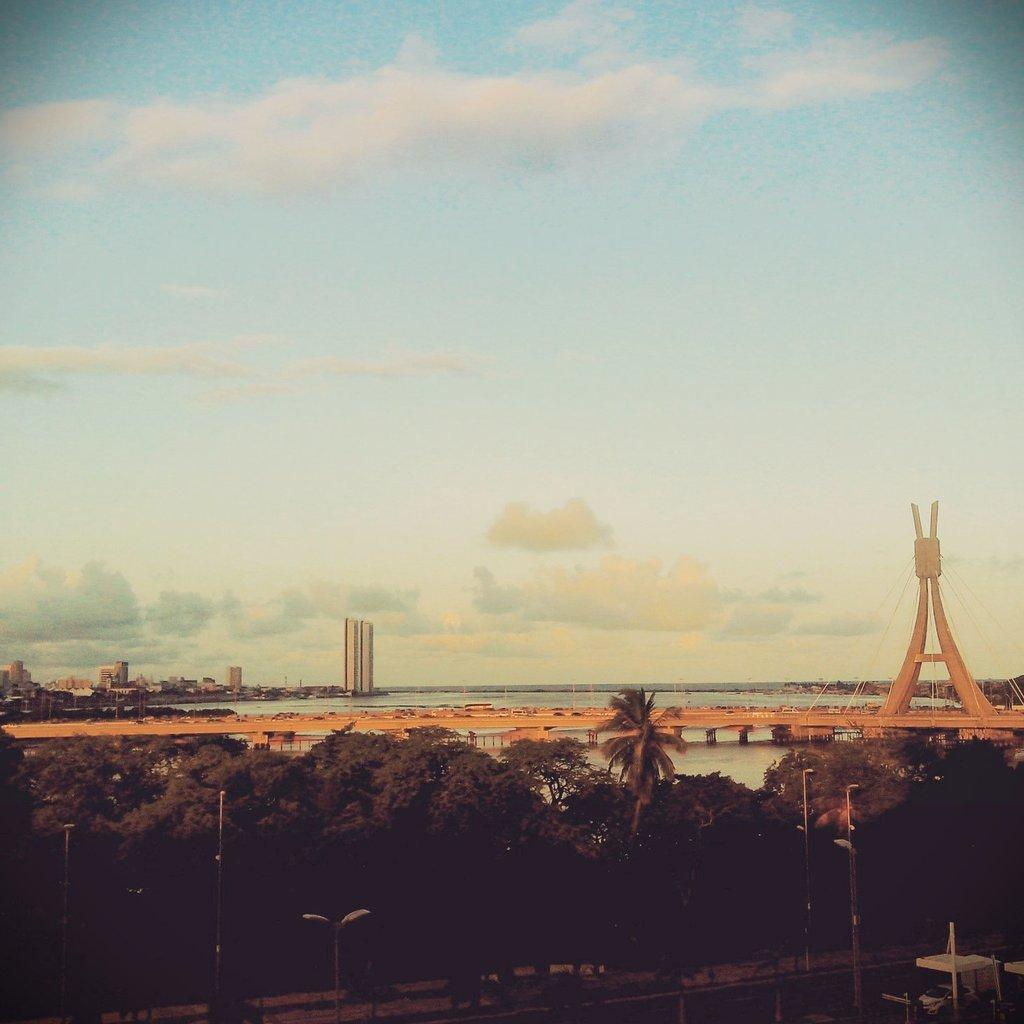What type of natural elements can be seen in the image? There are trees in the image. What type of artificial elements can be seen in the image? There are street lights, a bridge, skyscrapers, and buildings in the image. What is visible in the sky in the image? Clouds are visible in the sky. What type of waste can be seen in the image? There is no waste present in the image. What type of wine is being served in the image? There is no wine present in the image. 